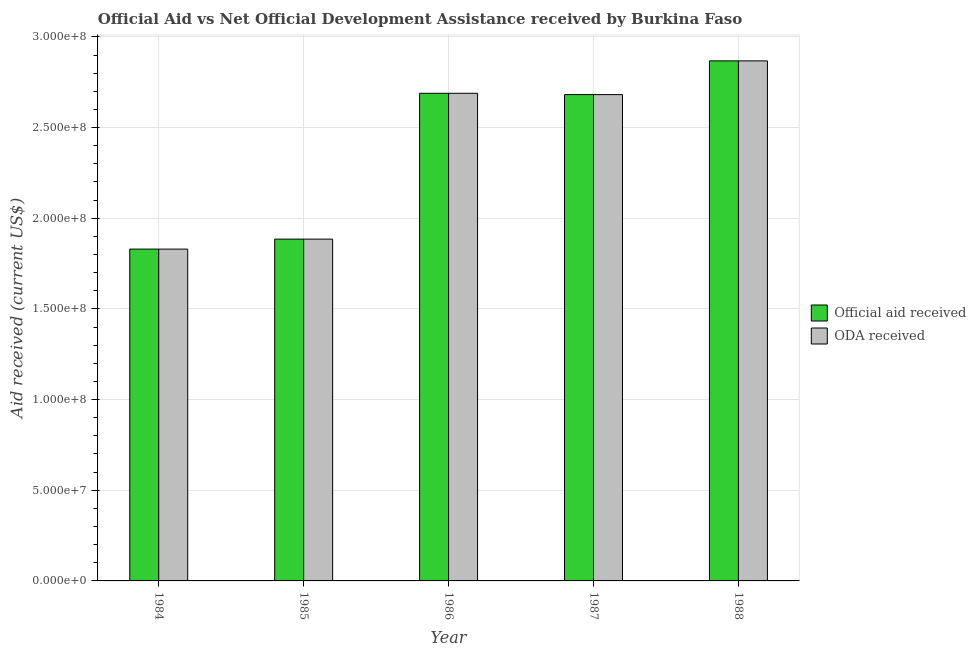How many different coloured bars are there?
Make the answer very short. 2. How many groups of bars are there?
Offer a terse response. 5. Are the number of bars per tick equal to the number of legend labels?
Provide a short and direct response. Yes. How many bars are there on the 5th tick from the right?
Keep it short and to the point. 2. What is the label of the 1st group of bars from the left?
Provide a short and direct response. 1984. What is the oda received in 1987?
Your answer should be compact. 2.68e+08. Across all years, what is the maximum official aid received?
Keep it short and to the point. 2.87e+08. Across all years, what is the minimum official aid received?
Your answer should be compact. 1.83e+08. What is the total oda received in the graph?
Offer a terse response. 1.20e+09. What is the difference between the oda received in 1986 and that in 1988?
Your answer should be compact. -1.79e+07. What is the difference between the official aid received in 1986 and the oda received in 1987?
Your answer should be very brief. 7.30e+05. What is the average oda received per year?
Ensure brevity in your answer.  2.39e+08. In the year 1985, what is the difference between the oda received and official aid received?
Provide a succinct answer. 0. In how many years, is the official aid received greater than 290000000 US$?
Your answer should be very brief. 0. What is the ratio of the official aid received in 1986 to that in 1987?
Offer a very short reply. 1. Is the difference between the oda received in 1986 and 1987 greater than the difference between the official aid received in 1986 and 1987?
Give a very brief answer. No. What is the difference between the highest and the second highest official aid received?
Keep it short and to the point. 1.79e+07. What is the difference between the highest and the lowest official aid received?
Keep it short and to the point. 1.04e+08. What does the 1st bar from the left in 1984 represents?
Give a very brief answer. Official aid received. What does the 2nd bar from the right in 1986 represents?
Provide a succinct answer. Official aid received. Are all the bars in the graph horizontal?
Your response must be concise. No. How many years are there in the graph?
Offer a terse response. 5. Are the values on the major ticks of Y-axis written in scientific E-notation?
Your response must be concise. Yes. Where does the legend appear in the graph?
Keep it short and to the point. Center right. What is the title of the graph?
Keep it short and to the point. Official Aid vs Net Official Development Assistance received by Burkina Faso . Does "GDP at market prices" appear as one of the legend labels in the graph?
Provide a succinct answer. No. What is the label or title of the Y-axis?
Offer a very short reply. Aid received (current US$). What is the Aid received (current US$) in Official aid received in 1984?
Make the answer very short. 1.83e+08. What is the Aid received (current US$) of ODA received in 1984?
Make the answer very short. 1.83e+08. What is the Aid received (current US$) in Official aid received in 1985?
Keep it short and to the point. 1.88e+08. What is the Aid received (current US$) in ODA received in 1985?
Your answer should be compact. 1.88e+08. What is the Aid received (current US$) in Official aid received in 1986?
Ensure brevity in your answer.  2.69e+08. What is the Aid received (current US$) of ODA received in 1986?
Provide a short and direct response. 2.69e+08. What is the Aid received (current US$) of Official aid received in 1987?
Offer a very short reply. 2.68e+08. What is the Aid received (current US$) of ODA received in 1987?
Provide a succinct answer. 2.68e+08. What is the Aid received (current US$) in Official aid received in 1988?
Keep it short and to the point. 2.87e+08. What is the Aid received (current US$) in ODA received in 1988?
Your response must be concise. 2.87e+08. Across all years, what is the maximum Aid received (current US$) in Official aid received?
Provide a succinct answer. 2.87e+08. Across all years, what is the maximum Aid received (current US$) of ODA received?
Ensure brevity in your answer.  2.87e+08. Across all years, what is the minimum Aid received (current US$) of Official aid received?
Keep it short and to the point. 1.83e+08. Across all years, what is the minimum Aid received (current US$) of ODA received?
Ensure brevity in your answer.  1.83e+08. What is the total Aid received (current US$) of Official aid received in the graph?
Your response must be concise. 1.20e+09. What is the total Aid received (current US$) in ODA received in the graph?
Give a very brief answer. 1.20e+09. What is the difference between the Aid received (current US$) in Official aid received in 1984 and that in 1985?
Provide a succinct answer. -5.51e+06. What is the difference between the Aid received (current US$) of ODA received in 1984 and that in 1985?
Keep it short and to the point. -5.51e+06. What is the difference between the Aid received (current US$) of Official aid received in 1984 and that in 1986?
Ensure brevity in your answer.  -8.59e+07. What is the difference between the Aid received (current US$) in ODA received in 1984 and that in 1986?
Your answer should be very brief. -8.59e+07. What is the difference between the Aid received (current US$) of Official aid received in 1984 and that in 1987?
Your answer should be very brief. -8.52e+07. What is the difference between the Aid received (current US$) in ODA received in 1984 and that in 1987?
Your answer should be very brief. -8.52e+07. What is the difference between the Aid received (current US$) of Official aid received in 1984 and that in 1988?
Your response must be concise. -1.04e+08. What is the difference between the Aid received (current US$) of ODA received in 1984 and that in 1988?
Make the answer very short. -1.04e+08. What is the difference between the Aid received (current US$) of Official aid received in 1985 and that in 1986?
Offer a terse response. -8.04e+07. What is the difference between the Aid received (current US$) of ODA received in 1985 and that in 1986?
Offer a terse response. -8.04e+07. What is the difference between the Aid received (current US$) in Official aid received in 1985 and that in 1987?
Make the answer very short. -7.97e+07. What is the difference between the Aid received (current US$) in ODA received in 1985 and that in 1987?
Offer a very short reply. -7.97e+07. What is the difference between the Aid received (current US$) in Official aid received in 1985 and that in 1988?
Provide a succinct answer. -9.83e+07. What is the difference between the Aid received (current US$) of ODA received in 1985 and that in 1988?
Offer a very short reply. -9.83e+07. What is the difference between the Aid received (current US$) in Official aid received in 1986 and that in 1987?
Offer a terse response. 7.30e+05. What is the difference between the Aid received (current US$) of ODA received in 1986 and that in 1987?
Your answer should be very brief. 7.30e+05. What is the difference between the Aid received (current US$) of Official aid received in 1986 and that in 1988?
Give a very brief answer. -1.79e+07. What is the difference between the Aid received (current US$) in ODA received in 1986 and that in 1988?
Your answer should be very brief. -1.79e+07. What is the difference between the Aid received (current US$) in Official aid received in 1987 and that in 1988?
Your response must be concise. -1.86e+07. What is the difference between the Aid received (current US$) in ODA received in 1987 and that in 1988?
Give a very brief answer. -1.86e+07. What is the difference between the Aid received (current US$) in Official aid received in 1984 and the Aid received (current US$) in ODA received in 1985?
Provide a short and direct response. -5.51e+06. What is the difference between the Aid received (current US$) in Official aid received in 1984 and the Aid received (current US$) in ODA received in 1986?
Give a very brief answer. -8.59e+07. What is the difference between the Aid received (current US$) of Official aid received in 1984 and the Aid received (current US$) of ODA received in 1987?
Your answer should be very brief. -8.52e+07. What is the difference between the Aid received (current US$) of Official aid received in 1984 and the Aid received (current US$) of ODA received in 1988?
Ensure brevity in your answer.  -1.04e+08. What is the difference between the Aid received (current US$) in Official aid received in 1985 and the Aid received (current US$) in ODA received in 1986?
Provide a succinct answer. -8.04e+07. What is the difference between the Aid received (current US$) of Official aid received in 1985 and the Aid received (current US$) of ODA received in 1987?
Offer a very short reply. -7.97e+07. What is the difference between the Aid received (current US$) in Official aid received in 1985 and the Aid received (current US$) in ODA received in 1988?
Keep it short and to the point. -9.83e+07. What is the difference between the Aid received (current US$) of Official aid received in 1986 and the Aid received (current US$) of ODA received in 1987?
Offer a very short reply. 7.30e+05. What is the difference between the Aid received (current US$) of Official aid received in 1986 and the Aid received (current US$) of ODA received in 1988?
Offer a terse response. -1.79e+07. What is the difference between the Aid received (current US$) in Official aid received in 1987 and the Aid received (current US$) in ODA received in 1988?
Keep it short and to the point. -1.86e+07. What is the average Aid received (current US$) of Official aid received per year?
Keep it short and to the point. 2.39e+08. What is the average Aid received (current US$) of ODA received per year?
Give a very brief answer. 2.39e+08. In the year 1984, what is the difference between the Aid received (current US$) of Official aid received and Aid received (current US$) of ODA received?
Your answer should be very brief. 0. In the year 1986, what is the difference between the Aid received (current US$) in Official aid received and Aid received (current US$) in ODA received?
Your answer should be compact. 0. What is the ratio of the Aid received (current US$) in Official aid received in 1984 to that in 1985?
Your answer should be compact. 0.97. What is the ratio of the Aid received (current US$) in ODA received in 1984 to that in 1985?
Your answer should be very brief. 0.97. What is the ratio of the Aid received (current US$) of Official aid received in 1984 to that in 1986?
Offer a terse response. 0.68. What is the ratio of the Aid received (current US$) of ODA received in 1984 to that in 1986?
Your answer should be compact. 0.68. What is the ratio of the Aid received (current US$) of Official aid received in 1984 to that in 1987?
Ensure brevity in your answer.  0.68. What is the ratio of the Aid received (current US$) in ODA received in 1984 to that in 1987?
Offer a very short reply. 0.68. What is the ratio of the Aid received (current US$) of Official aid received in 1984 to that in 1988?
Keep it short and to the point. 0.64. What is the ratio of the Aid received (current US$) in ODA received in 1984 to that in 1988?
Your response must be concise. 0.64. What is the ratio of the Aid received (current US$) in Official aid received in 1985 to that in 1986?
Provide a short and direct response. 0.7. What is the ratio of the Aid received (current US$) in ODA received in 1985 to that in 1986?
Ensure brevity in your answer.  0.7. What is the ratio of the Aid received (current US$) of Official aid received in 1985 to that in 1987?
Offer a very short reply. 0.7. What is the ratio of the Aid received (current US$) of ODA received in 1985 to that in 1987?
Keep it short and to the point. 0.7. What is the ratio of the Aid received (current US$) of Official aid received in 1985 to that in 1988?
Ensure brevity in your answer.  0.66. What is the ratio of the Aid received (current US$) of ODA received in 1985 to that in 1988?
Make the answer very short. 0.66. What is the ratio of the Aid received (current US$) in ODA received in 1986 to that in 1987?
Keep it short and to the point. 1. What is the ratio of the Aid received (current US$) in Official aid received in 1986 to that in 1988?
Provide a succinct answer. 0.94. What is the ratio of the Aid received (current US$) in ODA received in 1986 to that in 1988?
Your response must be concise. 0.94. What is the ratio of the Aid received (current US$) in Official aid received in 1987 to that in 1988?
Keep it short and to the point. 0.94. What is the ratio of the Aid received (current US$) of ODA received in 1987 to that in 1988?
Your answer should be very brief. 0.94. What is the difference between the highest and the second highest Aid received (current US$) in Official aid received?
Make the answer very short. 1.79e+07. What is the difference between the highest and the second highest Aid received (current US$) of ODA received?
Provide a succinct answer. 1.79e+07. What is the difference between the highest and the lowest Aid received (current US$) of Official aid received?
Make the answer very short. 1.04e+08. What is the difference between the highest and the lowest Aid received (current US$) in ODA received?
Offer a very short reply. 1.04e+08. 